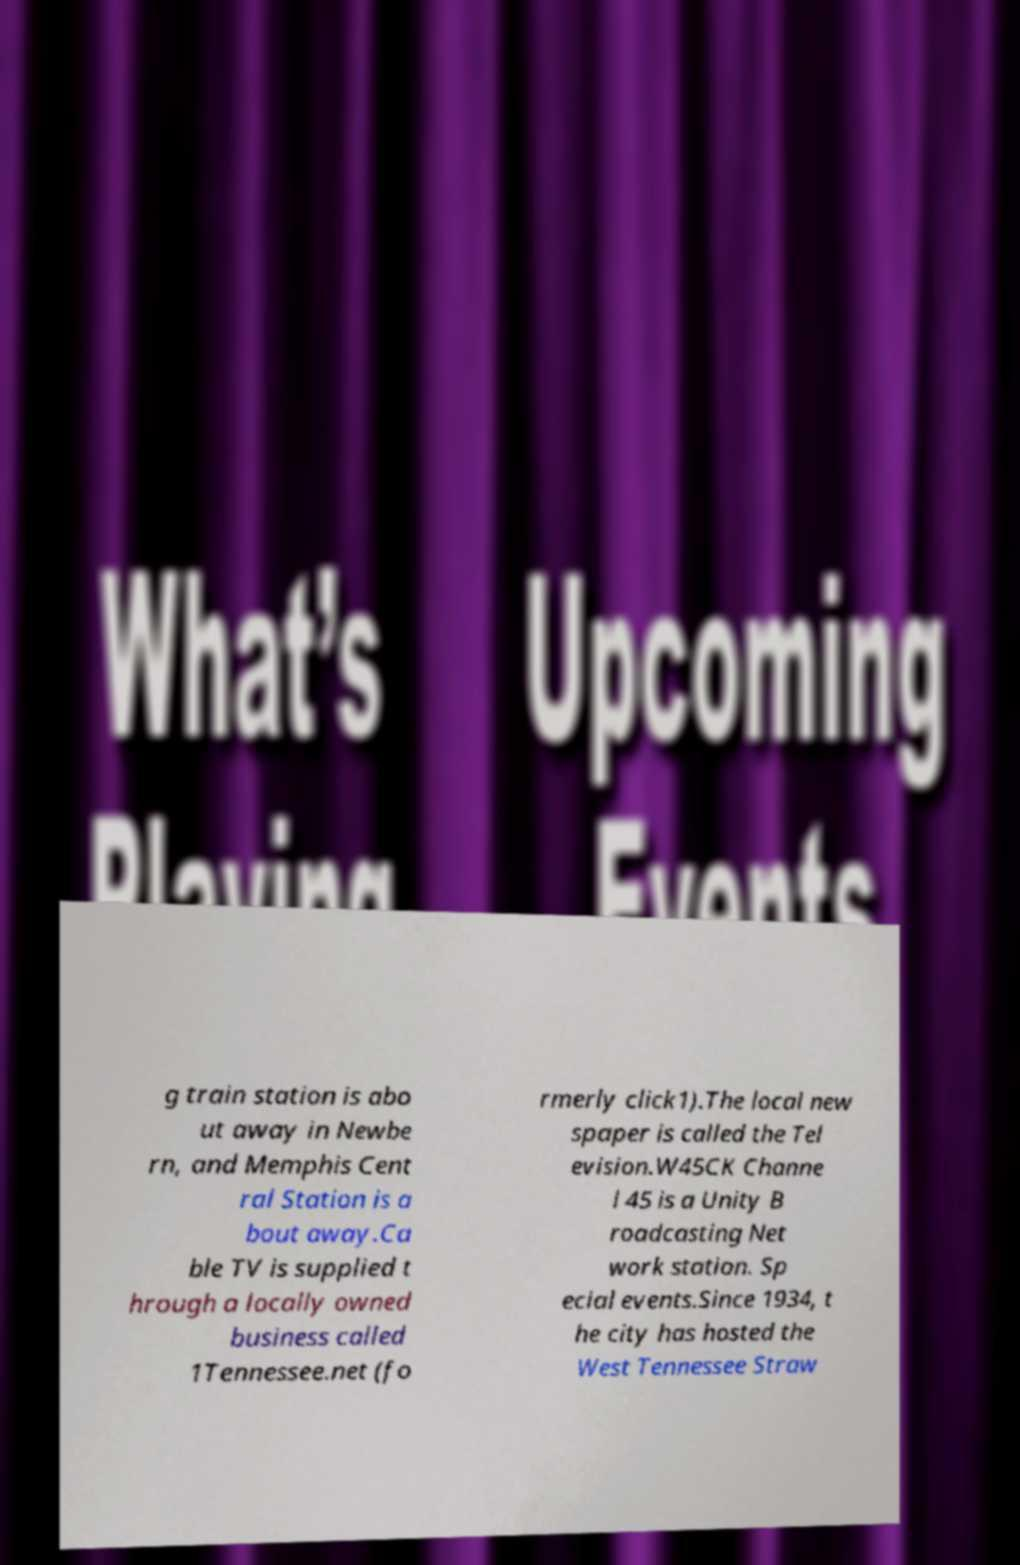Please identify and transcribe the text found in this image. g train station is abo ut away in Newbe rn, and Memphis Cent ral Station is a bout away.Ca ble TV is supplied t hrough a locally owned business called 1Tennessee.net (fo rmerly click1).The local new spaper is called the Tel evision.W45CK Channe l 45 is a Unity B roadcasting Net work station. Sp ecial events.Since 1934, t he city has hosted the West Tennessee Straw 